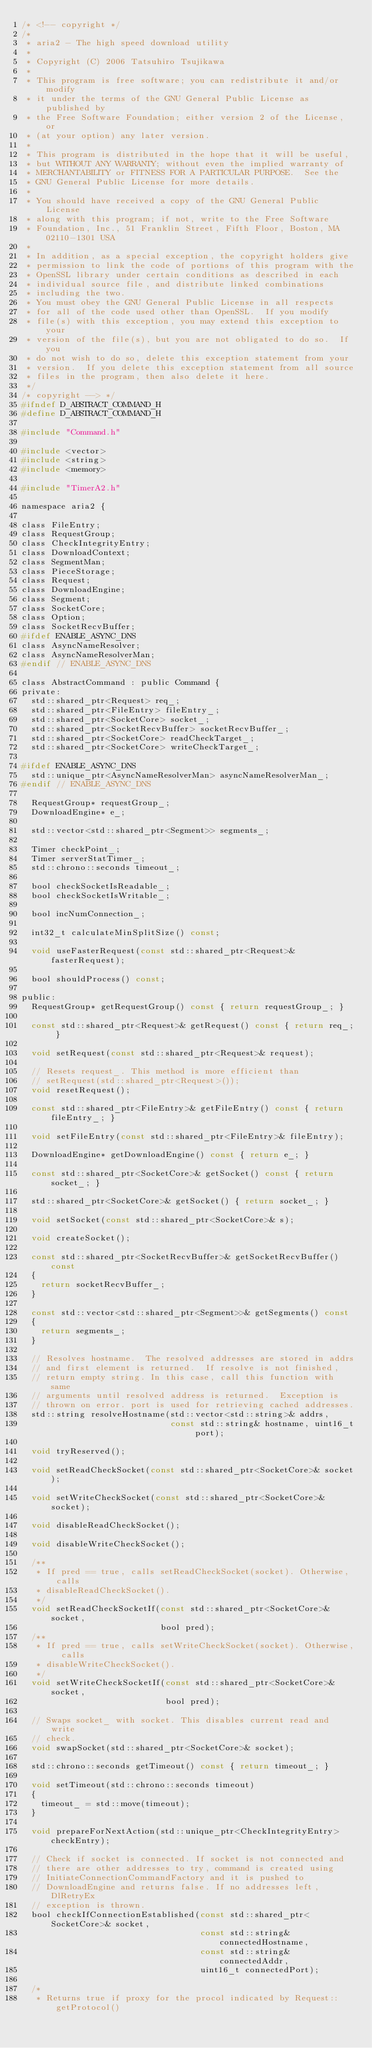<code> <loc_0><loc_0><loc_500><loc_500><_C_>/* <!-- copyright */
/*
 * aria2 - The high speed download utility
 *
 * Copyright (C) 2006 Tatsuhiro Tsujikawa
 *
 * This program is free software; you can redistribute it and/or modify
 * it under the terms of the GNU General Public License as published by
 * the Free Software Foundation; either version 2 of the License, or
 * (at your option) any later version.
 *
 * This program is distributed in the hope that it will be useful,
 * but WITHOUT ANY WARRANTY; without even the implied warranty of
 * MERCHANTABILITY or FITNESS FOR A PARTICULAR PURPOSE.  See the
 * GNU General Public License for more details.
 *
 * You should have received a copy of the GNU General Public License
 * along with this program; if not, write to the Free Software
 * Foundation, Inc., 51 Franklin Street, Fifth Floor, Boston, MA 02110-1301 USA
 *
 * In addition, as a special exception, the copyright holders give
 * permission to link the code of portions of this program with the
 * OpenSSL library under certain conditions as described in each
 * individual source file, and distribute linked combinations
 * including the two.
 * You must obey the GNU General Public License in all respects
 * for all of the code used other than OpenSSL.  If you modify
 * file(s) with this exception, you may extend this exception to your
 * version of the file(s), but you are not obligated to do so.  If you
 * do not wish to do so, delete this exception statement from your
 * version.  If you delete this exception statement from all source
 * files in the program, then also delete it here.
 */
/* copyright --> */
#ifndef D_ABSTRACT_COMMAND_H
#define D_ABSTRACT_COMMAND_H

#include "Command.h"

#include <vector>
#include <string>
#include <memory>

#include "TimerA2.h"

namespace aria2 {

class FileEntry;
class RequestGroup;
class CheckIntegrityEntry;
class DownloadContext;
class SegmentMan;
class PieceStorage;
class Request;
class DownloadEngine;
class Segment;
class SocketCore;
class Option;
class SocketRecvBuffer;
#ifdef ENABLE_ASYNC_DNS
class AsyncNameResolver;
class AsyncNameResolverMan;
#endif // ENABLE_ASYNC_DNS

class AbstractCommand : public Command {
private:
  std::shared_ptr<Request> req_;
  std::shared_ptr<FileEntry> fileEntry_;
  std::shared_ptr<SocketCore> socket_;
  std::shared_ptr<SocketRecvBuffer> socketRecvBuffer_;
  std::shared_ptr<SocketCore> readCheckTarget_;
  std::shared_ptr<SocketCore> writeCheckTarget_;

#ifdef ENABLE_ASYNC_DNS
  std::unique_ptr<AsyncNameResolverMan> asyncNameResolverMan_;
#endif // ENABLE_ASYNC_DNS

  RequestGroup* requestGroup_;
  DownloadEngine* e_;

  std::vector<std::shared_ptr<Segment>> segments_;

  Timer checkPoint_;
  Timer serverStatTimer_;
  std::chrono::seconds timeout_;

  bool checkSocketIsReadable_;
  bool checkSocketIsWritable_;

  bool incNumConnection_;

  int32_t calculateMinSplitSize() const;

  void useFasterRequest(const std::shared_ptr<Request>& fasterRequest);

  bool shouldProcess() const;

public:
  RequestGroup* getRequestGroup() const { return requestGroup_; }

  const std::shared_ptr<Request>& getRequest() const { return req_; }

  void setRequest(const std::shared_ptr<Request>& request);

  // Resets request_. This method is more efficient than
  // setRequest(std::shared_ptr<Request>());
  void resetRequest();

  const std::shared_ptr<FileEntry>& getFileEntry() const { return fileEntry_; }

  void setFileEntry(const std::shared_ptr<FileEntry>& fileEntry);

  DownloadEngine* getDownloadEngine() const { return e_; }

  const std::shared_ptr<SocketCore>& getSocket() const { return socket_; }

  std::shared_ptr<SocketCore>& getSocket() { return socket_; }

  void setSocket(const std::shared_ptr<SocketCore>& s);

  void createSocket();

  const std::shared_ptr<SocketRecvBuffer>& getSocketRecvBuffer() const
  {
    return socketRecvBuffer_;
  }

  const std::vector<std::shared_ptr<Segment>>& getSegments() const
  {
    return segments_;
  }

  // Resolves hostname.  The resolved addresses are stored in addrs
  // and first element is returned.  If resolve is not finished,
  // return empty string. In this case, call this function with same
  // arguments until resolved address is returned.  Exception is
  // thrown on error. port is used for retrieving cached addresses.
  std::string resolveHostname(std::vector<std::string>& addrs,
                              const std::string& hostname, uint16_t port);

  void tryReserved();

  void setReadCheckSocket(const std::shared_ptr<SocketCore>& socket);

  void setWriteCheckSocket(const std::shared_ptr<SocketCore>& socket);

  void disableReadCheckSocket();

  void disableWriteCheckSocket();

  /**
   * If pred == true, calls setReadCheckSocket(socket). Otherwise, calls
   * disableReadCheckSocket().
   */
  void setReadCheckSocketIf(const std::shared_ptr<SocketCore>& socket,
                            bool pred);
  /**
   * If pred == true, calls setWriteCheckSocket(socket). Otherwise, calls
   * disableWriteCheckSocket().
   */
  void setWriteCheckSocketIf(const std::shared_ptr<SocketCore>& socket,
                             bool pred);

  // Swaps socket_ with socket. This disables current read and write
  // check.
  void swapSocket(std::shared_ptr<SocketCore>& socket);

  std::chrono::seconds getTimeout() const { return timeout_; }

  void setTimeout(std::chrono::seconds timeout)
  {
    timeout_ = std::move(timeout);
  }

  void prepareForNextAction(std::unique_ptr<CheckIntegrityEntry> checkEntry);

  // Check if socket is connected. If socket is not connected and
  // there are other addresses to try, command is created using
  // InitiateConnectionCommandFactory and it is pushed to
  // DownloadEngine and returns false. If no addresses left, DlRetryEx
  // exception is thrown.
  bool checkIfConnectionEstablished(const std::shared_ptr<SocketCore>& socket,
                                    const std::string& connectedHostname,
                                    const std::string& connectedAddr,
                                    uint16_t connectedPort);

  /*
   * Returns true if proxy for the procol indicated by Request::getProtocol()</code> 